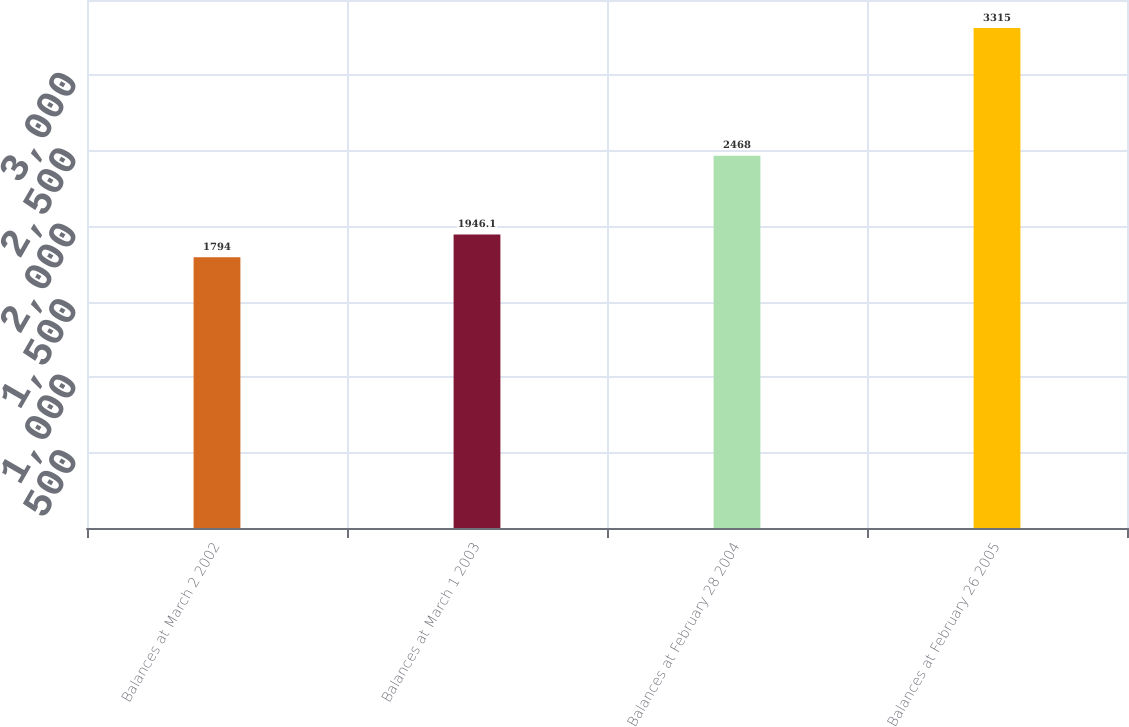Convert chart to OTSL. <chart><loc_0><loc_0><loc_500><loc_500><bar_chart><fcel>Balances at March 2 2002<fcel>Balances at March 1 2003<fcel>Balances at February 28 2004<fcel>Balances at February 26 2005<nl><fcel>1794<fcel>1946.1<fcel>2468<fcel>3315<nl></chart> 